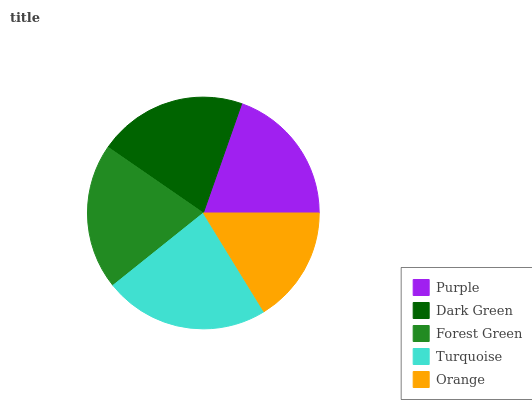Is Orange the minimum?
Answer yes or no. Yes. Is Turquoise the maximum?
Answer yes or no. Yes. Is Dark Green the minimum?
Answer yes or no. No. Is Dark Green the maximum?
Answer yes or no. No. Is Dark Green greater than Purple?
Answer yes or no. Yes. Is Purple less than Dark Green?
Answer yes or no. Yes. Is Purple greater than Dark Green?
Answer yes or no. No. Is Dark Green less than Purple?
Answer yes or no. No. Is Forest Green the high median?
Answer yes or no. Yes. Is Forest Green the low median?
Answer yes or no. Yes. Is Dark Green the high median?
Answer yes or no. No. Is Turquoise the low median?
Answer yes or no. No. 